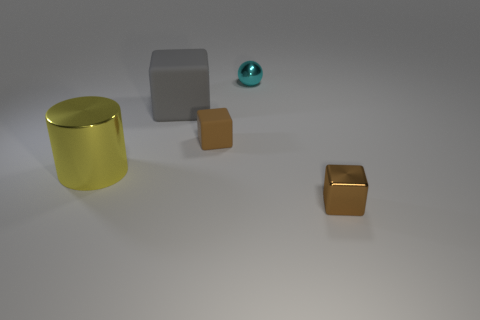Is there anything else of the same color as the small metallic cube?
Make the answer very short. Yes. What shape is the small brown object left of the object that is behind the gray rubber thing?
Your response must be concise. Cube. Are there more red spheres than large matte cubes?
Ensure brevity in your answer.  No. What number of objects are to the right of the big shiny cylinder and on the left side of the small ball?
Provide a succinct answer. 2. There is a metallic object that is on the left side of the small cyan sphere; how many yellow metallic objects are on the left side of it?
Provide a short and direct response. 0. How many things are either cubes that are on the right side of the big matte cube or metal objects that are behind the gray thing?
Make the answer very short. 3. There is another small thing that is the same shape as the brown rubber thing; what material is it?
Your answer should be very brief. Metal. How many things are either things right of the tiny cyan shiny ball or rubber objects?
Your response must be concise. 3. There is a brown object that is the same material as the big yellow object; what shape is it?
Provide a short and direct response. Cube. What number of other brown objects are the same shape as the tiny brown matte thing?
Provide a short and direct response. 1. 